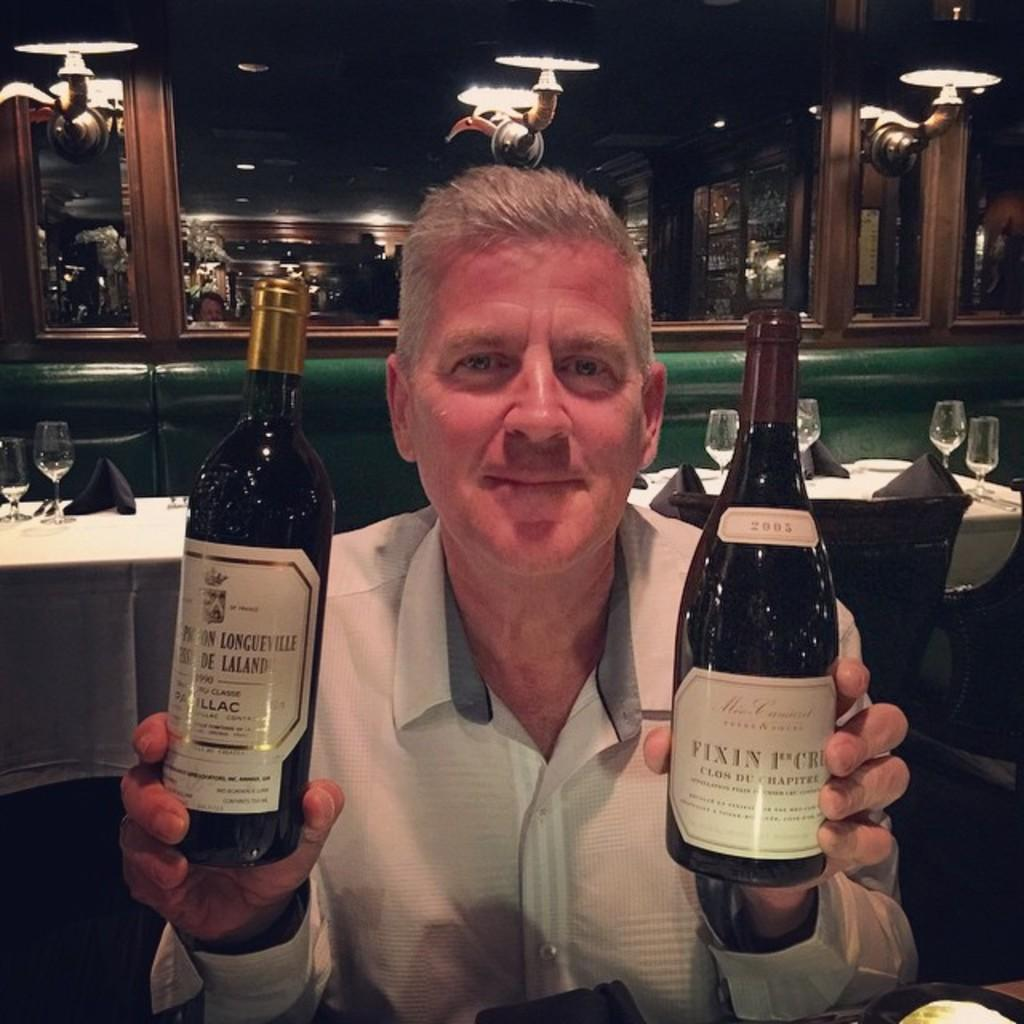<image>
Summarize the visual content of the image. The bottle on the left is from the vintage 1990 